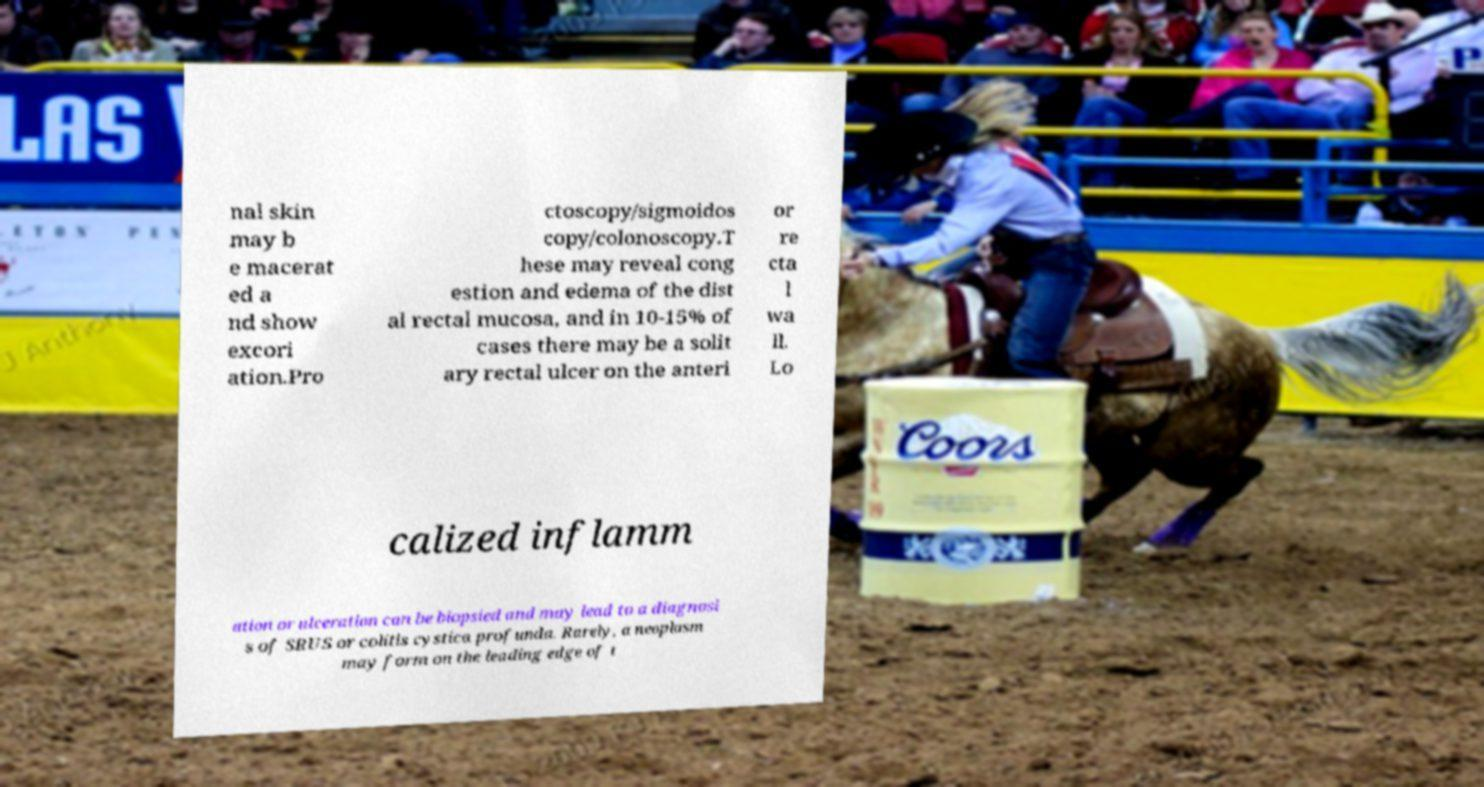Could you assist in decoding the text presented in this image and type it out clearly? nal skin may b e macerat ed a nd show excori ation.Pro ctoscopy/sigmoidos copy/colonoscopy.T hese may reveal cong estion and edema of the dist al rectal mucosa, and in 10-15% of cases there may be a solit ary rectal ulcer on the anteri or re cta l wa ll. Lo calized inflamm ation or ulceration can be biopsied and may lead to a diagnosi s of SRUS or colitis cystica profunda. Rarely, a neoplasm may form on the leading edge of t 